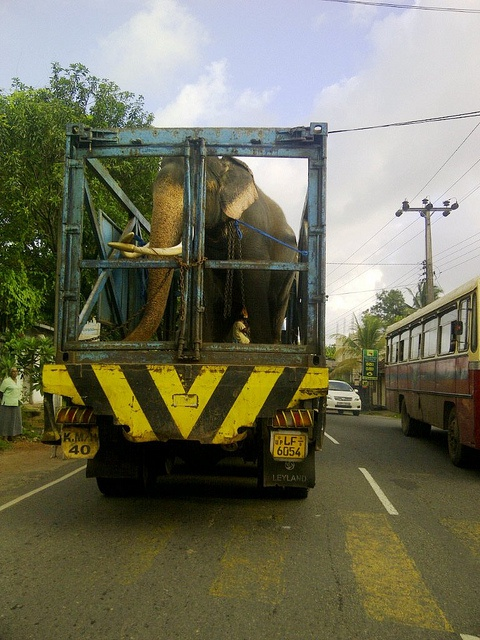Describe the objects in this image and their specific colors. I can see truck in lavender, black, darkgreen, gray, and olive tones, elephant in lavender, black, olive, and gray tones, bus in lavender, black, darkgray, and darkgreen tones, people in lavender, black, olive, and darkgreen tones, and car in lavender, gray, beige, and black tones in this image. 